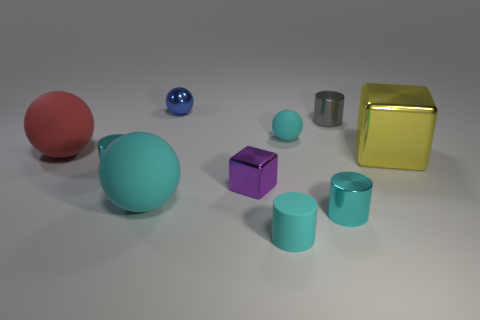Subtract all cyan balls. How many cyan cylinders are left? 3 Subtract all small blue balls. How many balls are left? 3 Subtract 1 balls. How many balls are left? 3 Subtract all blue spheres. How many spheres are left? 3 Subtract all purple cylinders. Subtract all gray balls. How many cylinders are left? 4 Subtract all spheres. How many objects are left? 6 Add 5 tiny gray metallic objects. How many tiny gray metallic objects are left? 6 Add 4 gray shiny cylinders. How many gray shiny cylinders exist? 5 Subtract 0 red cylinders. How many objects are left? 10 Subtract all small purple things. Subtract all balls. How many objects are left? 5 